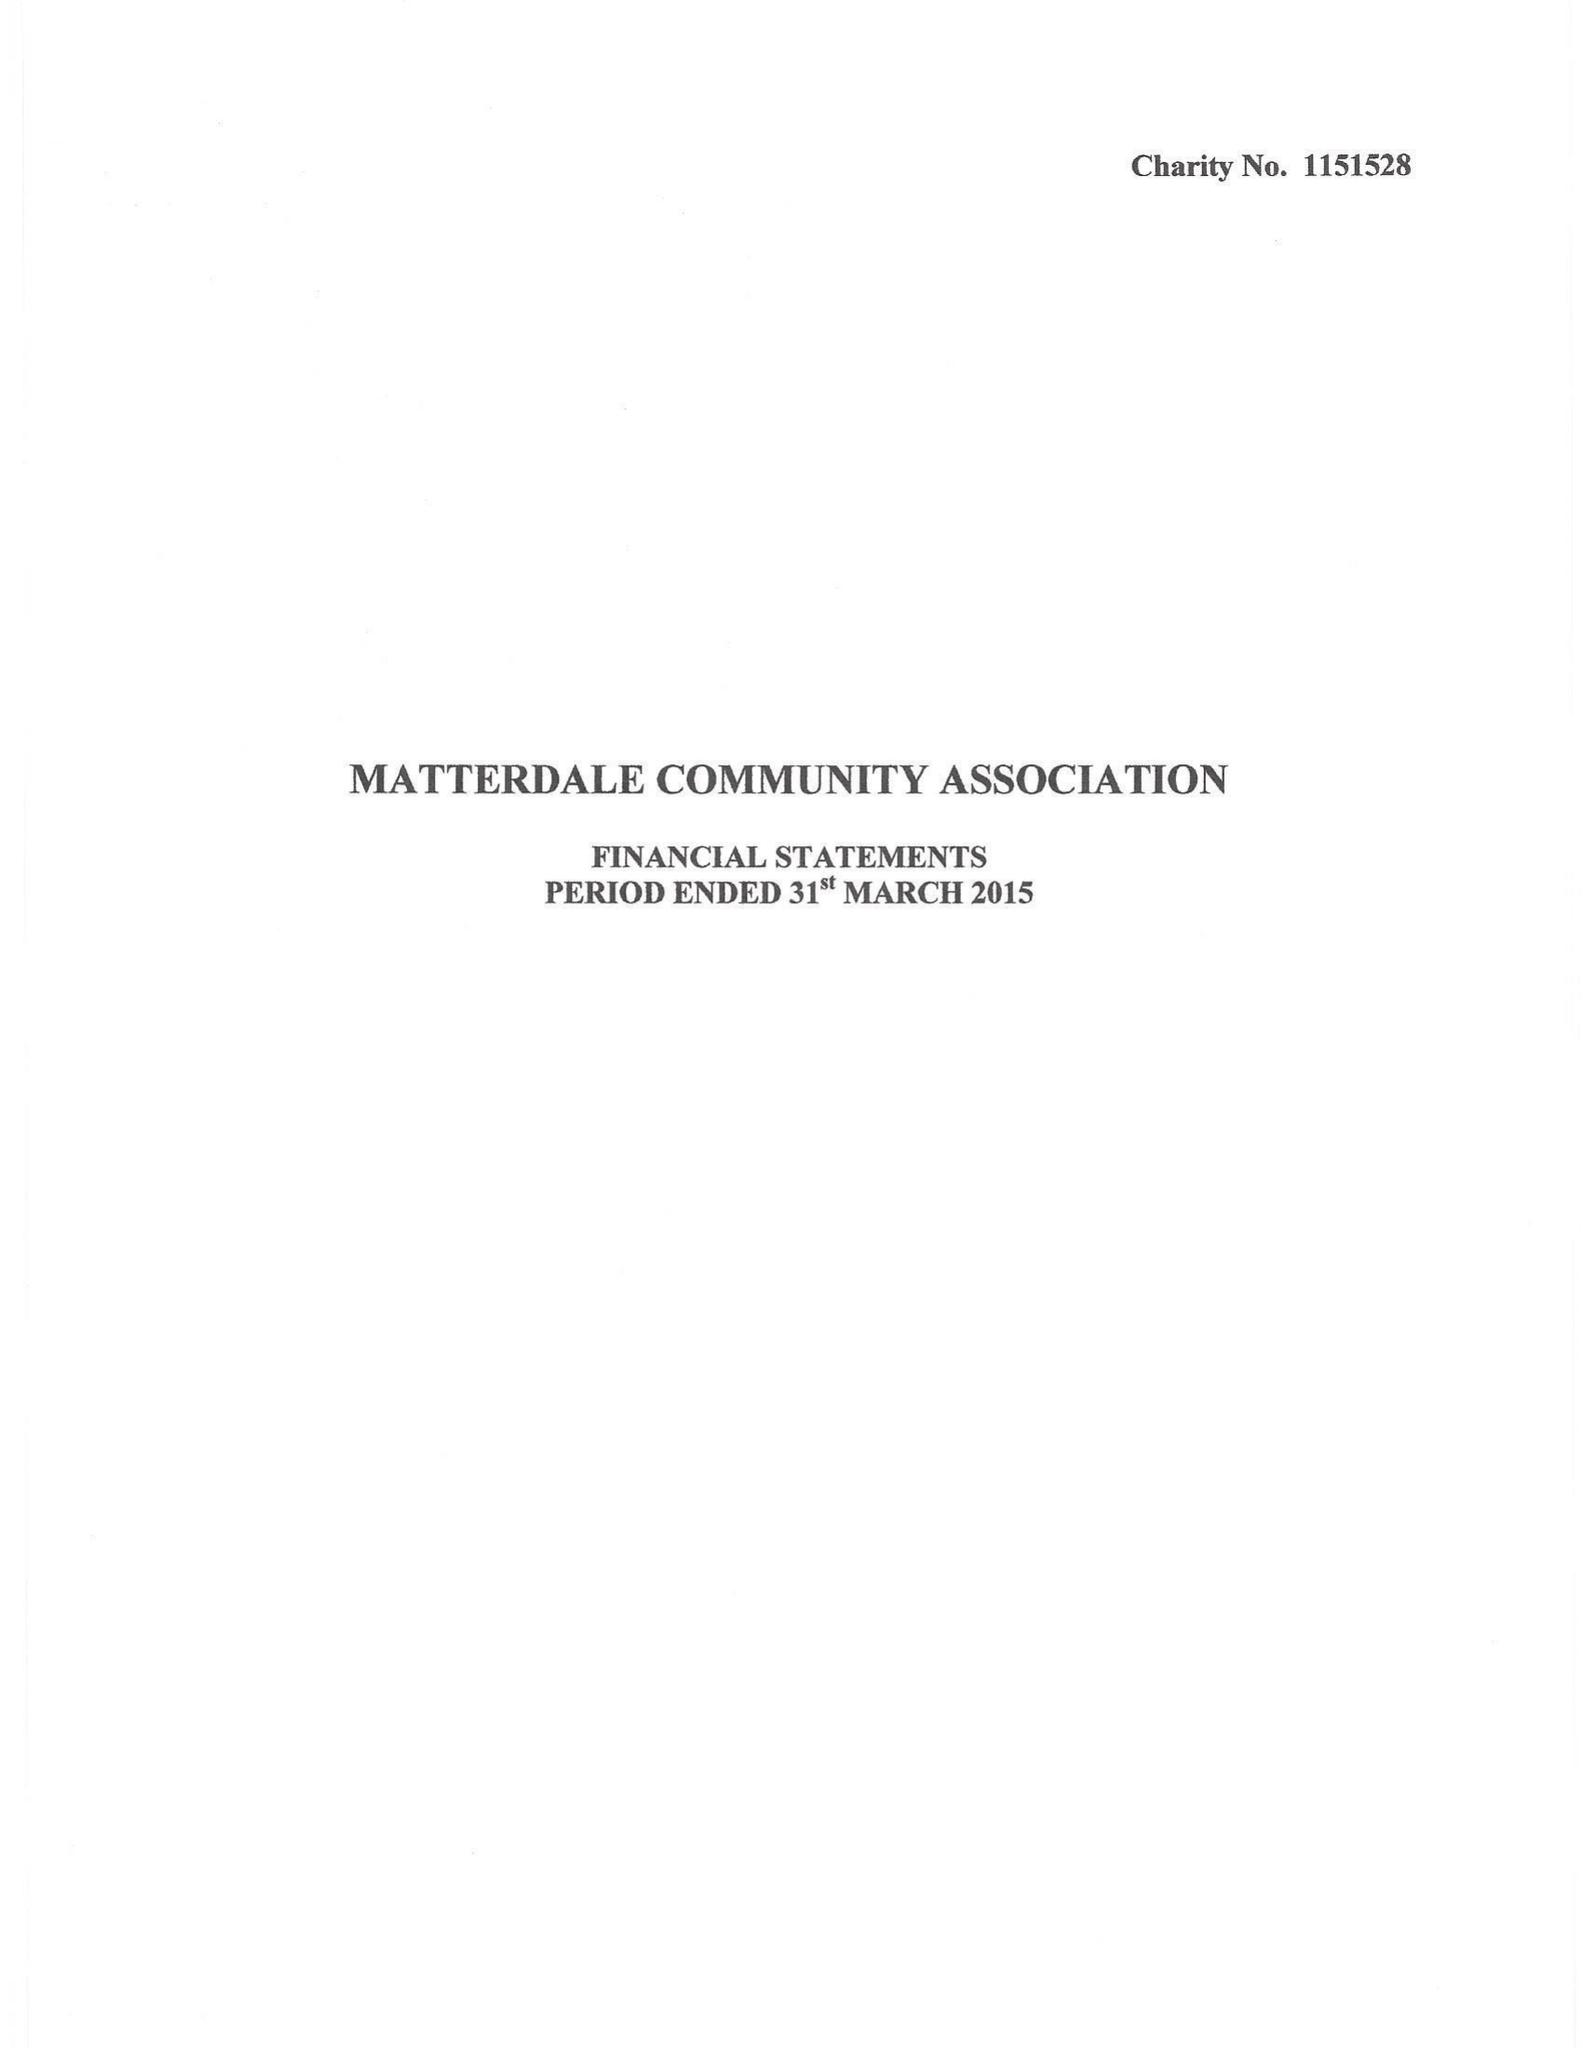What is the value for the income_annually_in_british_pounds?
Answer the question using a single word or phrase. None 